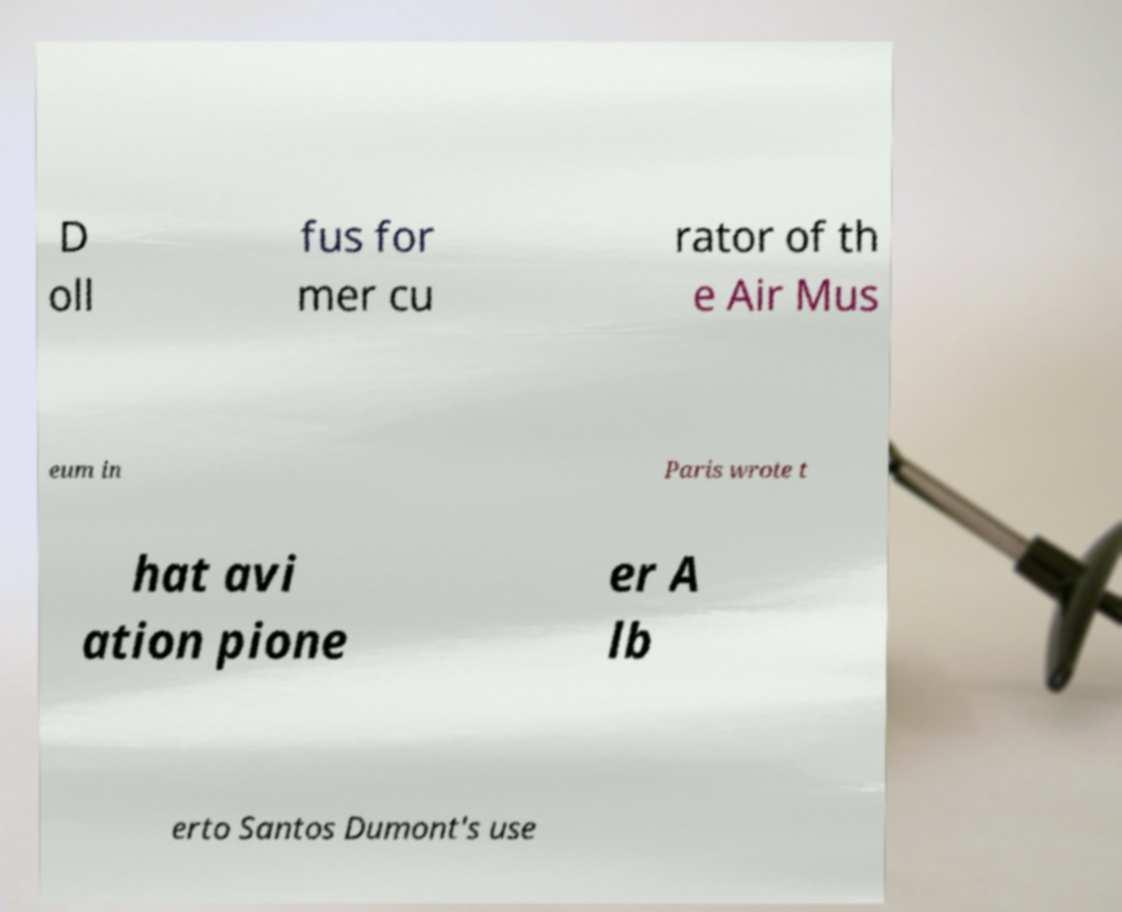There's text embedded in this image that I need extracted. Can you transcribe it verbatim? D oll fus for mer cu rator of th e Air Mus eum in Paris wrote t hat avi ation pione er A lb erto Santos Dumont's use 